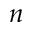Convert formula to latex. <formula><loc_0><loc_0><loc_500><loc_500>n</formula> 